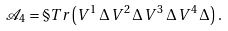Convert formula to latex. <formula><loc_0><loc_0><loc_500><loc_500>\mathcal { A } _ { 4 } = \S T r \left ( V ^ { 1 } \, \Delta \, V ^ { 2 } \, \Delta \, V ^ { 3 } \, \Delta \, V ^ { 4 } \, \Delta \right ) .</formula> 